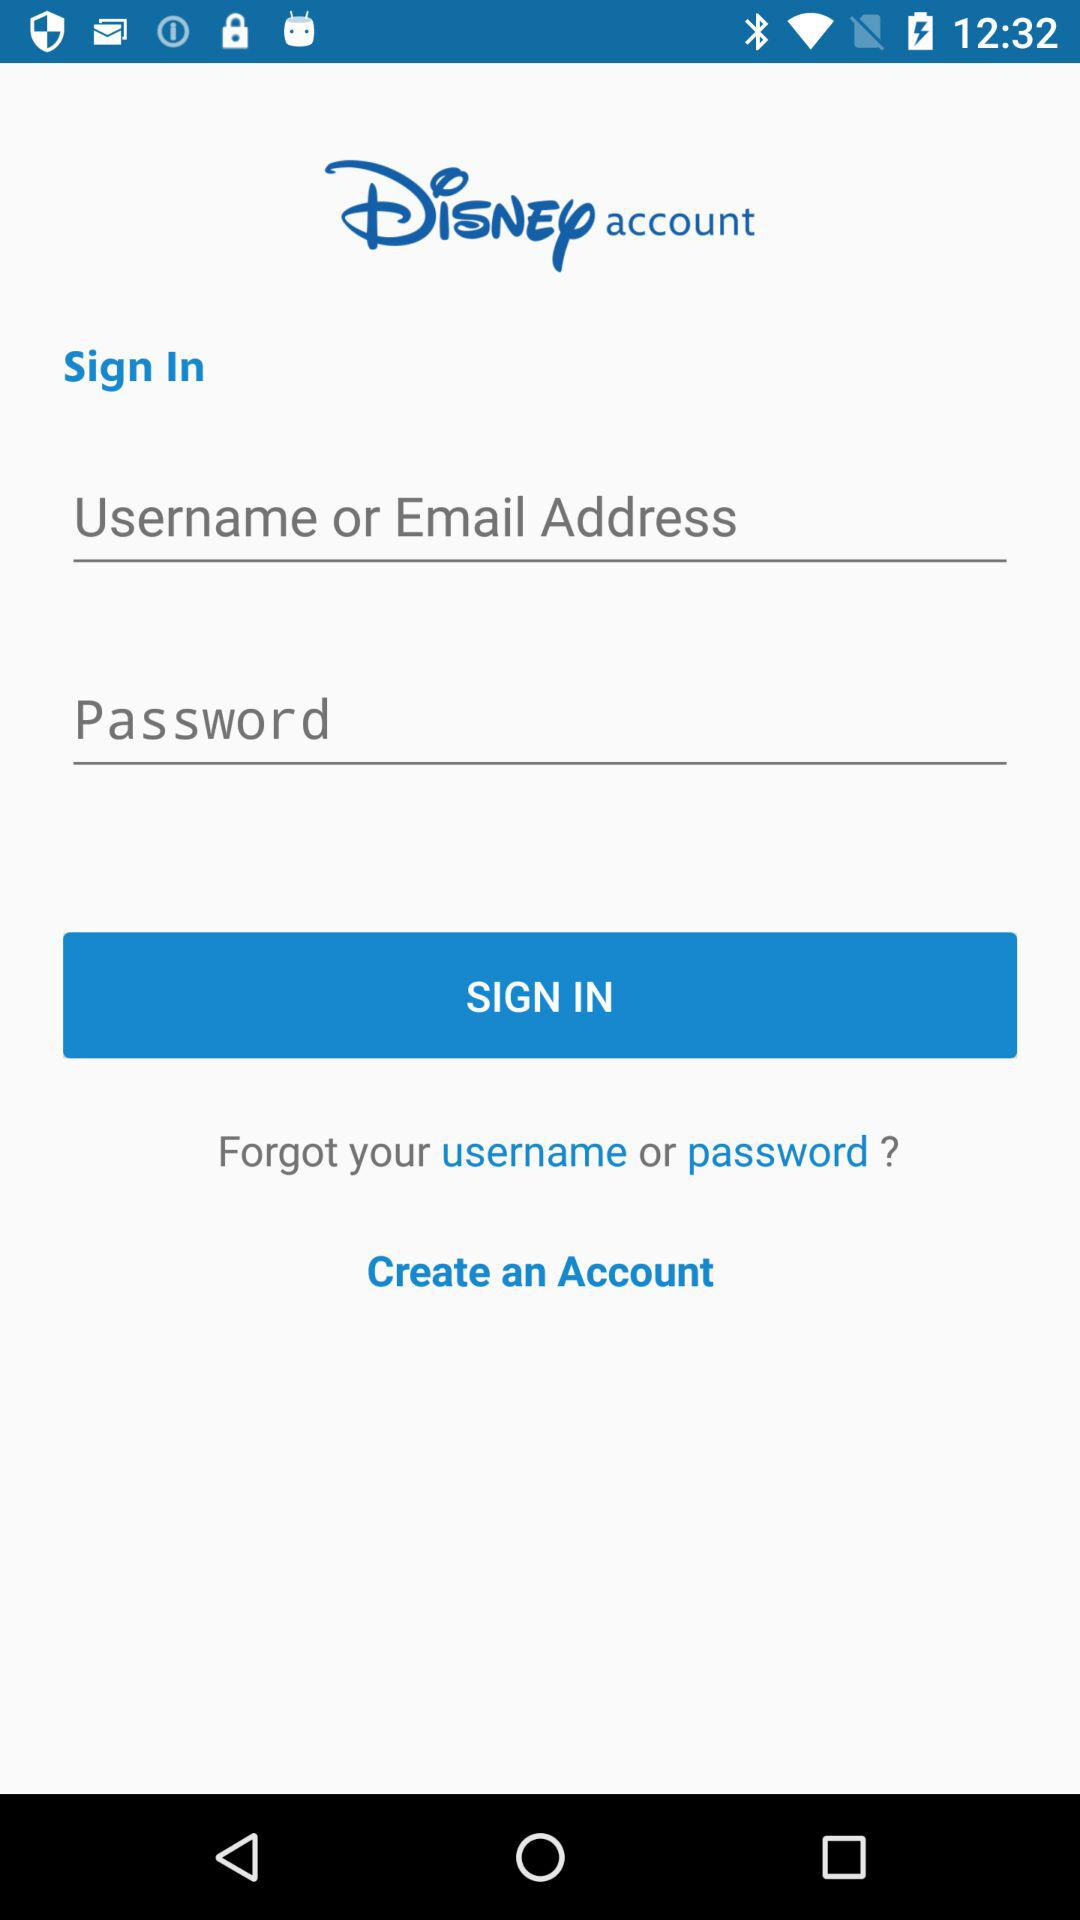What is the application name? The application name is "Disney". 